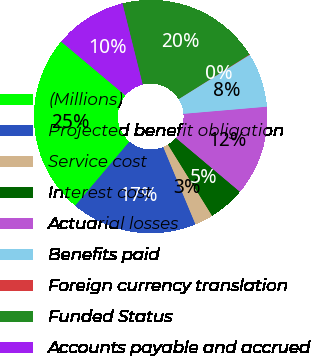<chart> <loc_0><loc_0><loc_500><loc_500><pie_chart><fcel>(Millions)<fcel>Projected benefit obligation<fcel>Service cost<fcel>Interest cost<fcel>Actuarial losses<fcel>Benefits paid<fcel>Foreign currency translation<fcel>Funded Status<fcel>Accounts payable and accrued<nl><fcel>24.92%<fcel>17.46%<fcel>2.55%<fcel>5.03%<fcel>12.49%<fcel>7.52%<fcel>0.06%<fcel>19.95%<fcel>10.01%<nl></chart> 